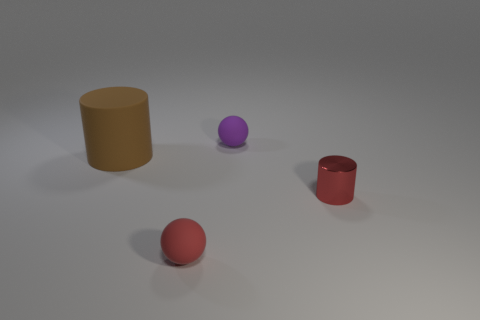There is a purple thing that is the same material as the big brown thing; what shape is it?
Offer a very short reply. Sphere. How many other things are the same shape as the large brown matte thing?
Offer a terse response. 1. There is a brown rubber cylinder; how many matte objects are in front of it?
Provide a succinct answer. 1. Is the size of the thing that is behind the big brown rubber cylinder the same as the cylinder that is right of the big rubber thing?
Your answer should be compact. Yes. How many other objects are there of the same size as the purple rubber ball?
Your answer should be compact. 2. There is a cylinder that is left of the small red thing that is to the right of the matte ball that is behind the small red ball; what is it made of?
Your answer should be compact. Rubber. There is a red ball; is it the same size as the cylinder that is right of the tiny purple rubber sphere?
Your answer should be very brief. Yes. There is a thing that is on the left side of the small purple rubber object and in front of the large brown matte cylinder; how big is it?
Your answer should be very brief. Small. Are there any other small cylinders that have the same color as the rubber cylinder?
Your response must be concise. No. There is a tiny rubber sphere left of the tiny object behind the small cylinder; what is its color?
Offer a very short reply. Red. 